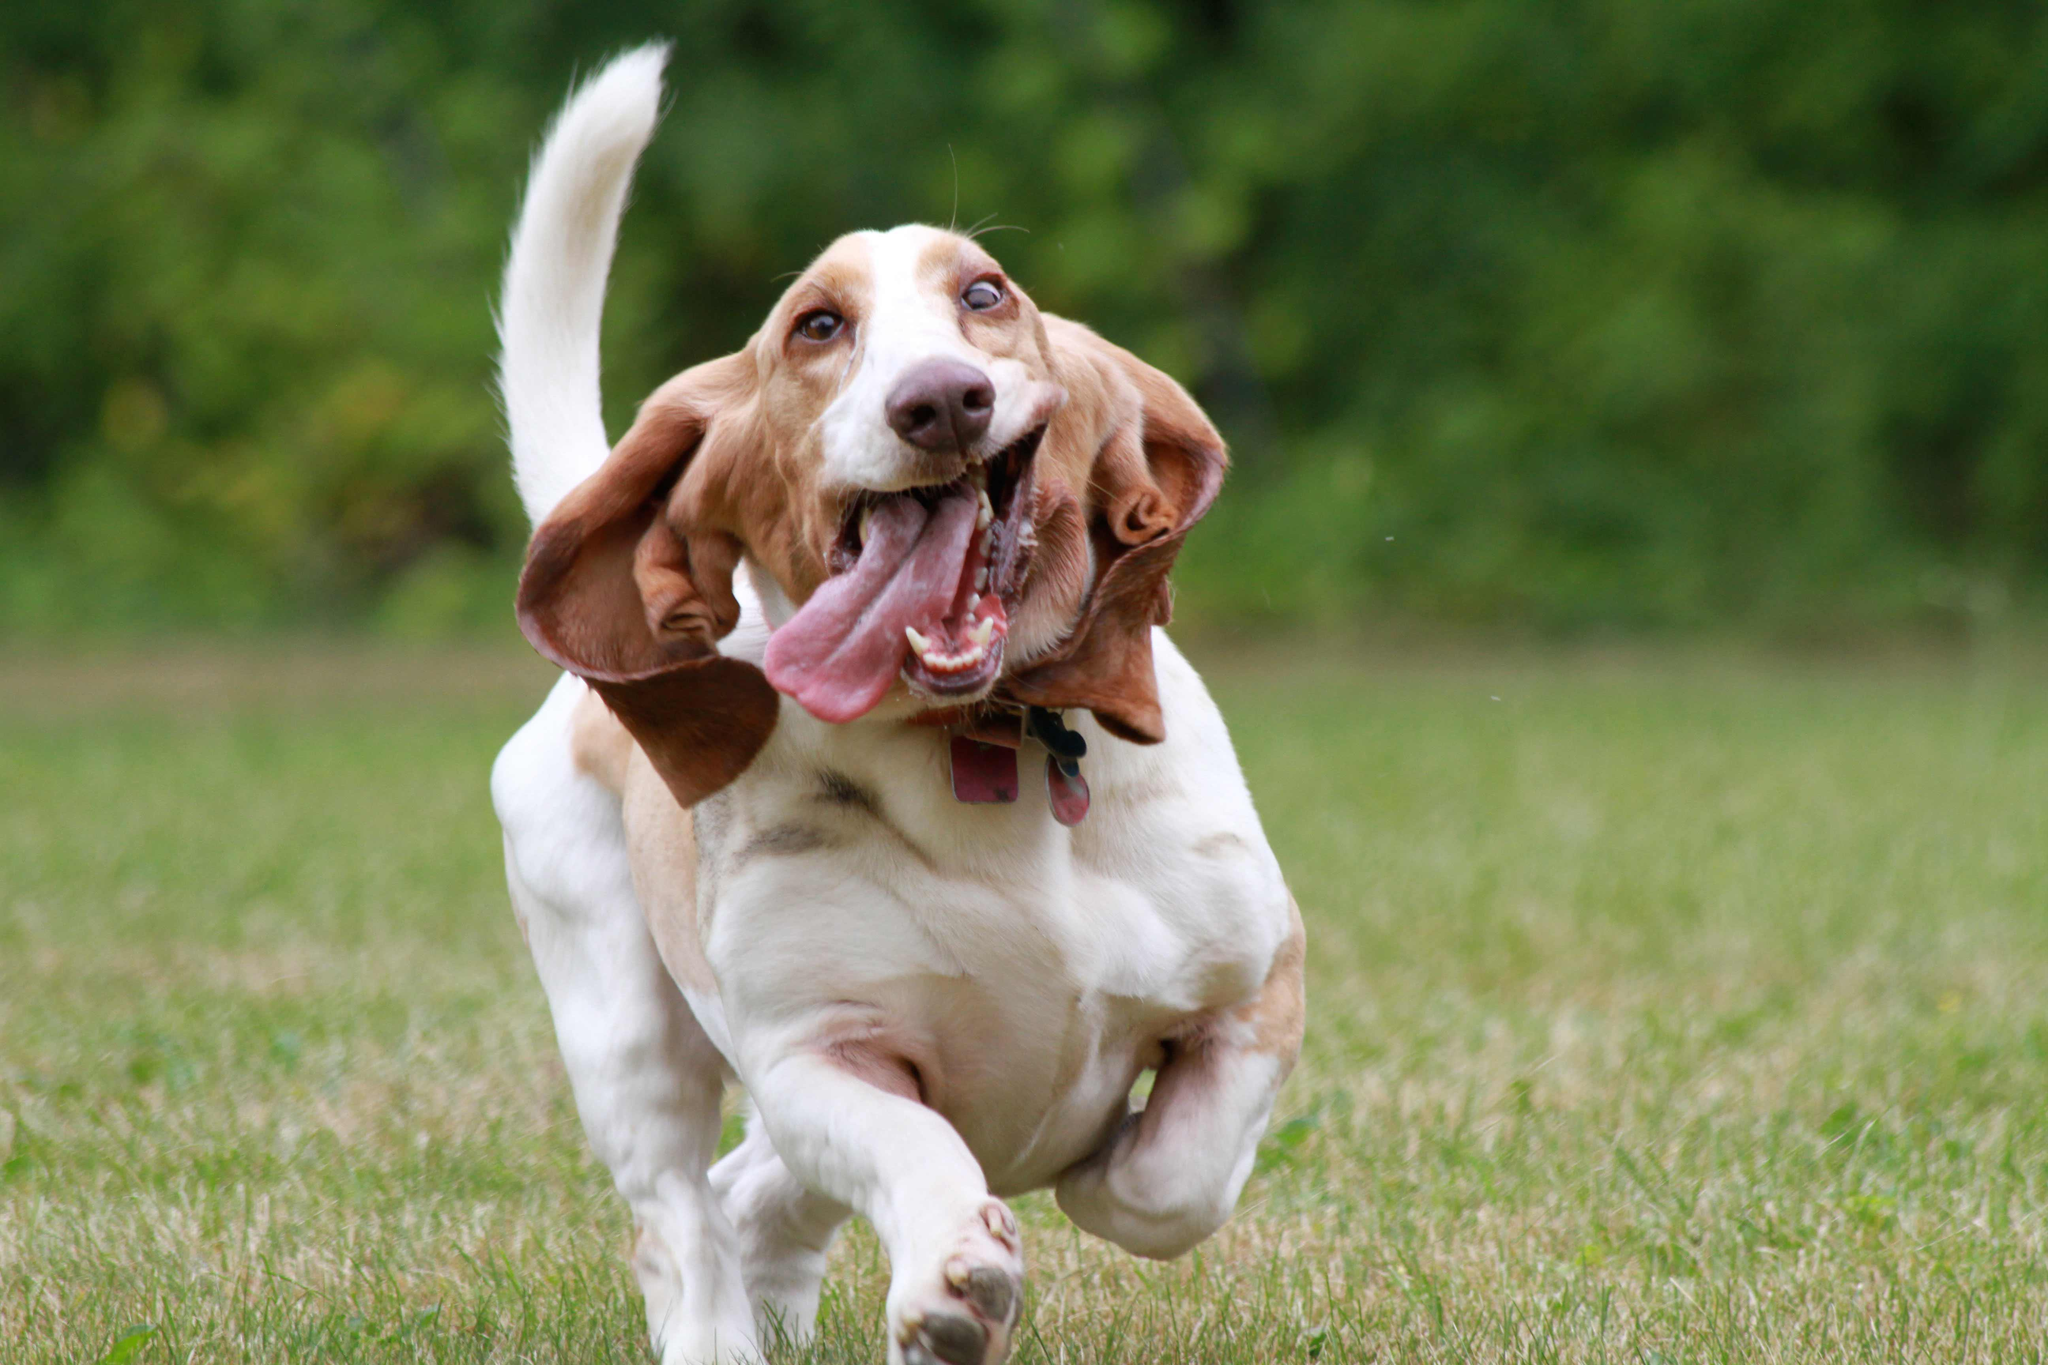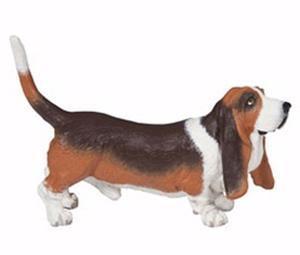The first image is the image on the left, the second image is the image on the right. Assess this claim about the two images: "The dog in the image on the right is against a white background.". Correct or not? Answer yes or no. Yes. 